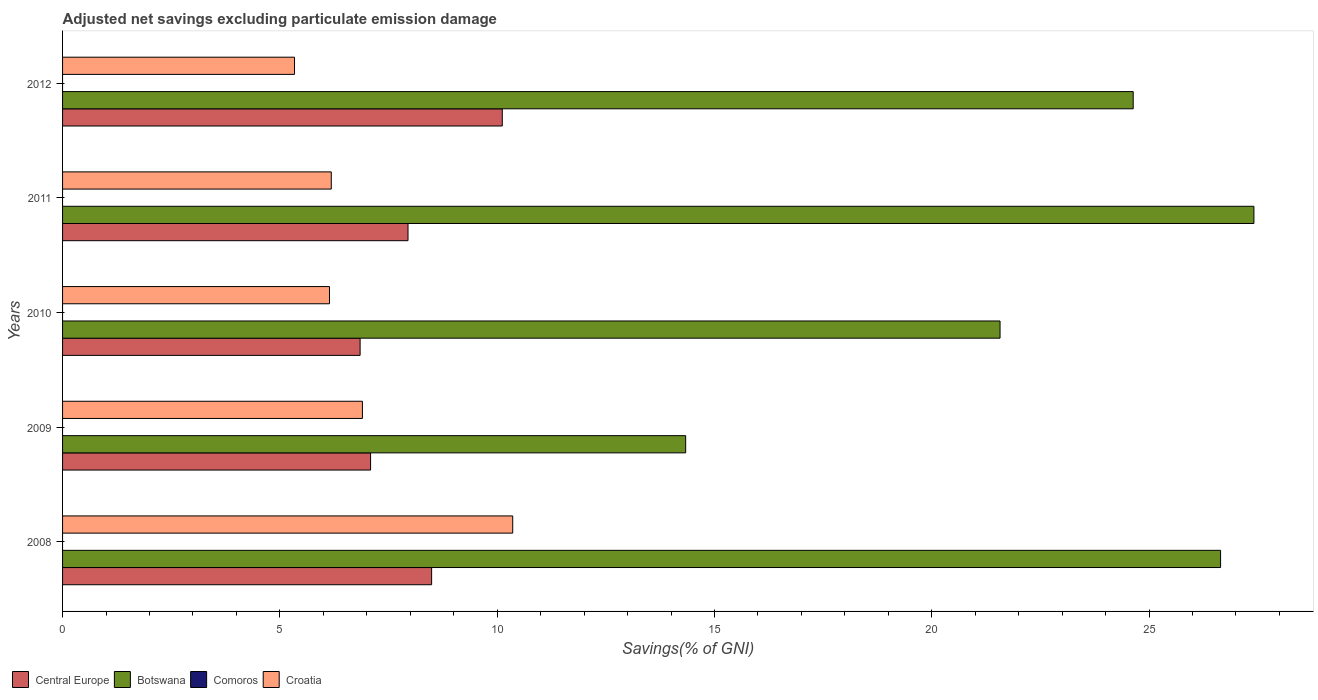Are the number of bars per tick equal to the number of legend labels?
Give a very brief answer. No. Are the number of bars on each tick of the Y-axis equal?
Offer a very short reply. Yes. How many bars are there on the 5th tick from the top?
Your answer should be compact. 3. What is the adjusted net savings in Croatia in 2012?
Offer a very short reply. 5.34. Across all years, what is the maximum adjusted net savings in Botswana?
Give a very brief answer. 27.41. Across all years, what is the minimum adjusted net savings in Croatia?
Offer a very short reply. 5.34. In which year was the adjusted net savings in Central Europe maximum?
Your answer should be very brief. 2012. What is the total adjusted net savings in Botswana in the graph?
Your answer should be very brief. 114.6. What is the difference between the adjusted net savings in Central Europe in 2009 and that in 2011?
Offer a very short reply. -0.86. What is the difference between the adjusted net savings in Croatia in 2011 and the adjusted net savings in Botswana in 2012?
Keep it short and to the point. -18.45. In the year 2012, what is the difference between the adjusted net savings in Botswana and adjusted net savings in Croatia?
Provide a short and direct response. 19.3. What is the ratio of the adjusted net savings in Botswana in 2010 to that in 2011?
Your response must be concise. 0.79. What is the difference between the highest and the second highest adjusted net savings in Central Europe?
Provide a short and direct response. 1.63. What is the difference between the highest and the lowest adjusted net savings in Croatia?
Your answer should be very brief. 5.02. In how many years, is the adjusted net savings in Croatia greater than the average adjusted net savings in Croatia taken over all years?
Your answer should be compact. 1. Is the sum of the adjusted net savings in Croatia in 2011 and 2012 greater than the maximum adjusted net savings in Central Europe across all years?
Provide a succinct answer. Yes. Is it the case that in every year, the sum of the adjusted net savings in Botswana and adjusted net savings in Central Europe is greater than the adjusted net savings in Comoros?
Make the answer very short. Yes. Are all the bars in the graph horizontal?
Keep it short and to the point. Yes. How many years are there in the graph?
Ensure brevity in your answer.  5. What is the difference between two consecutive major ticks on the X-axis?
Your answer should be very brief. 5. Are the values on the major ticks of X-axis written in scientific E-notation?
Offer a terse response. No. Does the graph contain any zero values?
Your response must be concise. Yes. Does the graph contain grids?
Offer a very short reply. No. How many legend labels are there?
Keep it short and to the point. 4. What is the title of the graph?
Make the answer very short. Adjusted net savings excluding particulate emission damage. What is the label or title of the X-axis?
Offer a very short reply. Savings(% of GNI). What is the label or title of the Y-axis?
Give a very brief answer. Years. What is the Savings(% of GNI) of Central Europe in 2008?
Keep it short and to the point. 8.49. What is the Savings(% of GNI) in Botswana in 2008?
Provide a succinct answer. 26.65. What is the Savings(% of GNI) of Croatia in 2008?
Ensure brevity in your answer.  10.36. What is the Savings(% of GNI) in Central Europe in 2009?
Your answer should be very brief. 7.09. What is the Savings(% of GNI) of Botswana in 2009?
Give a very brief answer. 14.34. What is the Savings(% of GNI) of Croatia in 2009?
Provide a succinct answer. 6.9. What is the Savings(% of GNI) of Central Europe in 2010?
Ensure brevity in your answer.  6.85. What is the Savings(% of GNI) of Botswana in 2010?
Give a very brief answer. 21.57. What is the Savings(% of GNI) in Croatia in 2010?
Give a very brief answer. 6.14. What is the Savings(% of GNI) of Central Europe in 2011?
Make the answer very short. 7.95. What is the Savings(% of GNI) of Botswana in 2011?
Offer a terse response. 27.41. What is the Savings(% of GNI) of Croatia in 2011?
Keep it short and to the point. 6.18. What is the Savings(% of GNI) in Central Europe in 2012?
Provide a short and direct response. 10.12. What is the Savings(% of GNI) in Botswana in 2012?
Provide a succinct answer. 24.63. What is the Savings(% of GNI) of Comoros in 2012?
Provide a short and direct response. 0. What is the Savings(% of GNI) in Croatia in 2012?
Your response must be concise. 5.34. Across all years, what is the maximum Savings(% of GNI) in Central Europe?
Your answer should be very brief. 10.12. Across all years, what is the maximum Savings(% of GNI) of Botswana?
Provide a succinct answer. 27.41. Across all years, what is the maximum Savings(% of GNI) of Croatia?
Provide a short and direct response. 10.36. Across all years, what is the minimum Savings(% of GNI) in Central Europe?
Offer a very short reply. 6.85. Across all years, what is the minimum Savings(% of GNI) in Botswana?
Your answer should be very brief. 14.34. Across all years, what is the minimum Savings(% of GNI) in Croatia?
Provide a short and direct response. 5.34. What is the total Savings(% of GNI) of Central Europe in the graph?
Your answer should be compact. 40.49. What is the total Savings(% of GNI) in Botswana in the graph?
Make the answer very short. 114.6. What is the total Savings(% of GNI) of Croatia in the graph?
Your answer should be compact. 34.92. What is the difference between the Savings(% of GNI) in Central Europe in 2008 and that in 2009?
Give a very brief answer. 1.4. What is the difference between the Savings(% of GNI) of Botswana in 2008 and that in 2009?
Your answer should be compact. 12.31. What is the difference between the Savings(% of GNI) of Croatia in 2008 and that in 2009?
Make the answer very short. 3.46. What is the difference between the Savings(% of GNI) of Central Europe in 2008 and that in 2010?
Give a very brief answer. 1.65. What is the difference between the Savings(% of GNI) of Botswana in 2008 and that in 2010?
Provide a short and direct response. 5.07. What is the difference between the Savings(% of GNI) of Croatia in 2008 and that in 2010?
Provide a succinct answer. 4.22. What is the difference between the Savings(% of GNI) of Central Europe in 2008 and that in 2011?
Provide a succinct answer. 0.54. What is the difference between the Savings(% of GNI) of Botswana in 2008 and that in 2011?
Make the answer very short. -0.77. What is the difference between the Savings(% of GNI) in Croatia in 2008 and that in 2011?
Your answer should be compact. 4.17. What is the difference between the Savings(% of GNI) of Central Europe in 2008 and that in 2012?
Your answer should be very brief. -1.63. What is the difference between the Savings(% of GNI) of Botswana in 2008 and that in 2012?
Keep it short and to the point. 2.01. What is the difference between the Savings(% of GNI) of Croatia in 2008 and that in 2012?
Offer a terse response. 5.02. What is the difference between the Savings(% of GNI) of Central Europe in 2009 and that in 2010?
Ensure brevity in your answer.  0.24. What is the difference between the Savings(% of GNI) of Botswana in 2009 and that in 2010?
Your response must be concise. -7.23. What is the difference between the Savings(% of GNI) in Croatia in 2009 and that in 2010?
Your response must be concise. 0.76. What is the difference between the Savings(% of GNI) of Central Europe in 2009 and that in 2011?
Provide a short and direct response. -0.86. What is the difference between the Savings(% of GNI) in Botswana in 2009 and that in 2011?
Keep it short and to the point. -13.08. What is the difference between the Savings(% of GNI) of Croatia in 2009 and that in 2011?
Provide a succinct answer. 0.72. What is the difference between the Savings(% of GNI) of Central Europe in 2009 and that in 2012?
Make the answer very short. -3.03. What is the difference between the Savings(% of GNI) of Botswana in 2009 and that in 2012?
Your response must be concise. -10.3. What is the difference between the Savings(% of GNI) in Croatia in 2009 and that in 2012?
Your answer should be compact. 1.56. What is the difference between the Savings(% of GNI) of Central Europe in 2010 and that in 2011?
Make the answer very short. -1.1. What is the difference between the Savings(% of GNI) of Botswana in 2010 and that in 2011?
Your answer should be compact. -5.84. What is the difference between the Savings(% of GNI) in Croatia in 2010 and that in 2011?
Make the answer very short. -0.04. What is the difference between the Savings(% of GNI) in Central Europe in 2010 and that in 2012?
Keep it short and to the point. -3.27. What is the difference between the Savings(% of GNI) of Botswana in 2010 and that in 2012?
Offer a terse response. -3.06. What is the difference between the Savings(% of GNI) in Croatia in 2010 and that in 2012?
Ensure brevity in your answer.  0.81. What is the difference between the Savings(% of GNI) in Central Europe in 2011 and that in 2012?
Keep it short and to the point. -2.17. What is the difference between the Savings(% of GNI) of Botswana in 2011 and that in 2012?
Keep it short and to the point. 2.78. What is the difference between the Savings(% of GNI) in Croatia in 2011 and that in 2012?
Ensure brevity in your answer.  0.85. What is the difference between the Savings(% of GNI) in Central Europe in 2008 and the Savings(% of GNI) in Botswana in 2009?
Provide a short and direct response. -5.85. What is the difference between the Savings(% of GNI) of Central Europe in 2008 and the Savings(% of GNI) of Croatia in 2009?
Offer a terse response. 1.59. What is the difference between the Savings(% of GNI) in Botswana in 2008 and the Savings(% of GNI) in Croatia in 2009?
Ensure brevity in your answer.  19.75. What is the difference between the Savings(% of GNI) in Central Europe in 2008 and the Savings(% of GNI) in Botswana in 2010?
Offer a terse response. -13.08. What is the difference between the Savings(% of GNI) of Central Europe in 2008 and the Savings(% of GNI) of Croatia in 2010?
Ensure brevity in your answer.  2.35. What is the difference between the Savings(% of GNI) of Botswana in 2008 and the Savings(% of GNI) of Croatia in 2010?
Your response must be concise. 20.5. What is the difference between the Savings(% of GNI) of Central Europe in 2008 and the Savings(% of GNI) of Botswana in 2011?
Provide a succinct answer. -18.92. What is the difference between the Savings(% of GNI) in Central Europe in 2008 and the Savings(% of GNI) in Croatia in 2011?
Offer a terse response. 2.31. What is the difference between the Savings(% of GNI) in Botswana in 2008 and the Savings(% of GNI) in Croatia in 2011?
Keep it short and to the point. 20.46. What is the difference between the Savings(% of GNI) in Central Europe in 2008 and the Savings(% of GNI) in Botswana in 2012?
Keep it short and to the point. -16.14. What is the difference between the Savings(% of GNI) in Central Europe in 2008 and the Savings(% of GNI) in Croatia in 2012?
Your answer should be compact. 3.16. What is the difference between the Savings(% of GNI) of Botswana in 2008 and the Savings(% of GNI) of Croatia in 2012?
Your answer should be very brief. 21.31. What is the difference between the Savings(% of GNI) of Central Europe in 2009 and the Savings(% of GNI) of Botswana in 2010?
Provide a short and direct response. -14.48. What is the difference between the Savings(% of GNI) in Central Europe in 2009 and the Savings(% of GNI) in Croatia in 2010?
Provide a short and direct response. 0.95. What is the difference between the Savings(% of GNI) in Botswana in 2009 and the Savings(% of GNI) in Croatia in 2010?
Offer a very short reply. 8.2. What is the difference between the Savings(% of GNI) of Central Europe in 2009 and the Savings(% of GNI) of Botswana in 2011?
Keep it short and to the point. -20.33. What is the difference between the Savings(% of GNI) of Central Europe in 2009 and the Savings(% of GNI) of Croatia in 2011?
Provide a short and direct response. 0.9. What is the difference between the Savings(% of GNI) of Botswana in 2009 and the Savings(% of GNI) of Croatia in 2011?
Your response must be concise. 8.15. What is the difference between the Savings(% of GNI) in Central Europe in 2009 and the Savings(% of GNI) in Botswana in 2012?
Your response must be concise. -17.55. What is the difference between the Savings(% of GNI) of Central Europe in 2009 and the Savings(% of GNI) of Croatia in 2012?
Keep it short and to the point. 1.75. What is the difference between the Savings(% of GNI) of Botswana in 2009 and the Savings(% of GNI) of Croatia in 2012?
Offer a very short reply. 9. What is the difference between the Savings(% of GNI) of Central Europe in 2010 and the Savings(% of GNI) of Botswana in 2011?
Make the answer very short. -20.57. What is the difference between the Savings(% of GNI) in Central Europe in 2010 and the Savings(% of GNI) in Croatia in 2011?
Make the answer very short. 0.66. What is the difference between the Savings(% of GNI) in Botswana in 2010 and the Savings(% of GNI) in Croatia in 2011?
Make the answer very short. 15.39. What is the difference between the Savings(% of GNI) in Central Europe in 2010 and the Savings(% of GNI) in Botswana in 2012?
Offer a terse response. -17.79. What is the difference between the Savings(% of GNI) of Central Europe in 2010 and the Savings(% of GNI) of Croatia in 2012?
Give a very brief answer. 1.51. What is the difference between the Savings(% of GNI) in Botswana in 2010 and the Savings(% of GNI) in Croatia in 2012?
Offer a terse response. 16.23. What is the difference between the Savings(% of GNI) of Central Europe in 2011 and the Savings(% of GNI) of Botswana in 2012?
Your response must be concise. -16.69. What is the difference between the Savings(% of GNI) of Central Europe in 2011 and the Savings(% of GNI) of Croatia in 2012?
Provide a succinct answer. 2.61. What is the difference between the Savings(% of GNI) of Botswana in 2011 and the Savings(% of GNI) of Croatia in 2012?
Provide a succinct answer. 22.08. What is the average Savings(% of GNI) in Central Europe per year?
Keep it short and to the point. 8.1. What is the average Savings(% of GNI) in Botswana per year?
Ensure brevity in your answer.  22.92. What is the average Savings(% of GNI) of Comoros per year?
Give a very brief answer. 0. What is the average Savings(% of GNI) in Croatia per year?
Provide a short and direct response. 6.98. In the year 2008, what is the difference between the Savings(% of GNI) of Central Europe and Savings(% of GNI) of Botswana?
Make the answer very short. -18.15. In the year 2008, what is the difference between the Savings(% of GNI) of Central Europe and Savings(% of GNI) of Croatia?
Provide a short and direct response. -1.87. In the year 2008, what is the difference between the Savings(% of GNI) of Botswana and Savings(% of GNI) of Croatia?
Provide a succinct answer. 16.29. In the year 2009, what is the difference between the Savings(% of GNI) in Central Europe and Savings(% of GNI) in Botswana?
Provide a succinct answer. -7.25. In the year 2009, what is the difference between the Savings(% of GNI) of Central Europe and Savings(% of GNI) of Croatia?
Give a very brief answer. 0.19. In the year 2009, what is the difference between the Savings(% of GNI) of Botswana and Savings(% of GNI) of Croatia?
Offer a terse response. 7.44. In the year 2010, what is the difference between the Savings(% of GNI) of Central Europe and Savings(% of GNI) of Botswana?
Make the answer very short. -14.72. In the year 2010, what is the difference between the Savings(% of GNI) of Central Europe and Savings(% of GNI) of Croatia?
Provide a short and direct response. 0.7. In the year 2010, what is the difference between the Savings(% of GNI) in Botswana and Savings(% of GNI) in Croatia?
Keep it short and to the point. 15.43. In the year 2011, what is the difference between the Savings(% of GNI) in Central Europe and Savings(% of GNI) in Botswana?
Offer a very short reply. -19.46. In the year 2011, what is the difference between the Savings(% of GNI) of Central Europe and Savings(% of GNI) of Croatia?
Make the answer very short. 1.77. In the year 2011, what is the difference between the Savings(% of GNI) of Botswana and Savings(% of GNI) of Croatia?
Your response must be concise. 21.23. In the year 2012, what is the difference between the Savings(% of GNI) in Central Europe and Savings(% of GNI) in Botswana?
Offer a very short reply. -14.52. In the year 2012, what is the difference between the Savings(% of GNI) of Central Europe and Savings(% of GNI) of Croatia?
Provide a succinct answer. 4.78. In the year 2012, what is the difference between the Savings(% of GNI) in Botswana and Savings(% of GNI) in Croatia?
Give a very brief answer. 19.3. What is the ratio of the Savings(% of GNI) of Central Europe in 2008 to that in 2009?
Provide a succinct answer. 1.2. What is the ratio of the Savings(% of GNI) of Botswana in 2008 to that in 2009?
Offer a terse response. 1.86. What is the ratio of the Savings(% of GNI) in Croatia in 2008 to that in 2009?
Your answer should be very brief. 1.5. What is the ratio of the Savings(% of GNI) in Central Europe in 2008 to that in 2010?
Offer a terse response. 1.24. What is the ratio of the Savings(% of GNI) of Botswana in 2008 to that in 2010?
Ensure brevity in your answer.  1.24. What is the ratio of the Savings(% of GNI) of Croatia in 2008 to that in 2010?
Your response must be concise. 1.69. What is the ratio of the Savings(% of GNI) of Central Europe in 2008 to that in 2011?
Your answer should be compact. 1.07. What is the ratio of the Savings(% of GNI) of Croatia in 2008 to that in 2011?
Offer a very short reply. 1.68. What is the ratio of the Savings(% of GNI) in Central Europe in 2008 to that in 2012?
Keep it short and to the point. 0.84. What is the ratio of the Savings(% of GNI) of Botswana in 2008 to that in 2012?
Your answer should be compact. 1.08. What is the ratio of the Savings(% of GNI) in Croatia in 2008 to that in 2012?
Your answer should be compact. 1.94. What is the ratio of the Savings(% of GNI) in Central Europe in 2009 to that in 2010?
Provide a short and direct response. 1.04. What is the ratio of the Savings(% of GNI) of Botswana in 2009 to that in 2010?
Your answer should be very brief. 0.66. What is the ratio of the Savings(% of GNI) of Croatia in 2009 to that in 2010?
Ensure brevity in your answer.  1.12. What is the ratio of the Savings(% of GNI) in Central Europe in 2009 to that in 2011?
Offer a terse response. 0.89. What is the ratio of the Savings(% of GNI) in Botswana in 2009 to that in 2011?
Offer a very short reply. 0.52. What is the ratio of the Savings(% of GNI) of Croatia in 2009 to that in 2011?
Keep it short and to the point. 1.12. What is the ratio of the Savings(% of GNI) in Central Europe in 2009 to that in 2012?
Your response must be concise. 0.7. What is the ratio of the Savings(% of GNI) of Botswana in 2009 to that in 2012?
Make the answer very short. 0.58. What is the ratio of the Savings(% of GNI) of Croatia in 2009 to that in 2012?
Give a very brief answer. 1.29. What is the ratio of the Savings(% of GNI) of Central Europe in 2010 to that in 2011?
Ensure brevity in your answer.  0.86. What is the ratio of the Savings(% of GNI) in Botswana in 2010 to that in 2011?
Make the answer very short. 0.79. What is the ratio of the Savings(% of GNI) of Croatia in 2010 to that in 2011?
Your response must be concise. 0.99. What is the ratio of the Savings(% of GNI) of Central Europe in 2010 to that in 2012?
Your answer should be compact. 0.68. What is the ratio of the Savings(% of GNI) of Botswana in 2010 to that in 2012?
Your response must be concise. 0.88. What is the ratio of the Savings(% of GNI) in Croatia in 2010 to that in 2012?
Provide a succinct answer. 1.15. What is the ratio of the Savings(% of GNI) of Central Europe in 2011 to that in 2012?
Give a very brief answer. 0.79. What is the ratio of the Savings(% of GNI) of Botswana in 2011 to that in 2012?
Provide a succinct answer. 1.11. What is the ratio of the Savings(% of GNI) in Croatia in 2011 to that in 2012?
Provide a short and direct response. 1.16. What is the difference between the highest and the second highest Savings(% of GNI) of Central Europe?
Your response must be concise. 1.63. What is the difference between the highest and the second highest Savings(% of GNI) in Botswana?
Keep it short and to the point. 0.77. What is the difference between the highest and the second highest Savings(% of GNI) in Croatia?
Provide a succinct answer. 3.46. What is the difference between the highest and the lowest Savings(% of GNI) of Central Europe?
Offer a very short reply. 3.27. What is the difference between the highest and the lowest Savings(% of GNI) in Botswana?
Keep it short and to the point. 13.08. What is the difference between the highest and the lowest Savings(% of GNI) in Croatia?
Give a very brief answer. 5.02. 